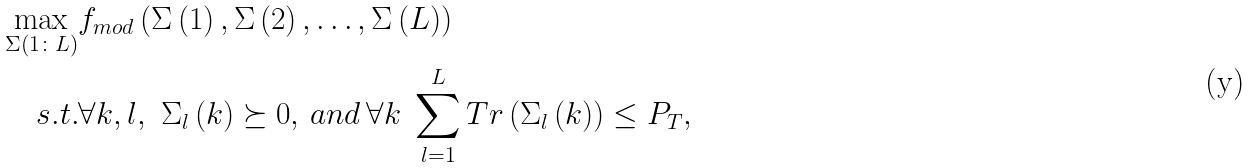Convert formula to latex. <formula><loc_0><loc_0><loc_500><loc_500>\underset { \Sigma ( 1 \colon L ) } { \max } & f _ { m o d } \left ( \Sigma \left ( 1 \right ) , \Sigma \left ( 2 \right ) , \dots , \Sigma \left ( L \right ) \right ) \\ s . t . & \forall k , l , \ \Sigma _ { l } \left ( k \right ) \succeq 0 , \, a n d \, \forall k \ \sum _ { l = 1 } ^ { L } T r \left ( \Sigma _ { l } \left ( k \right ) \right ) \leq P _ { T } ,</formula> 